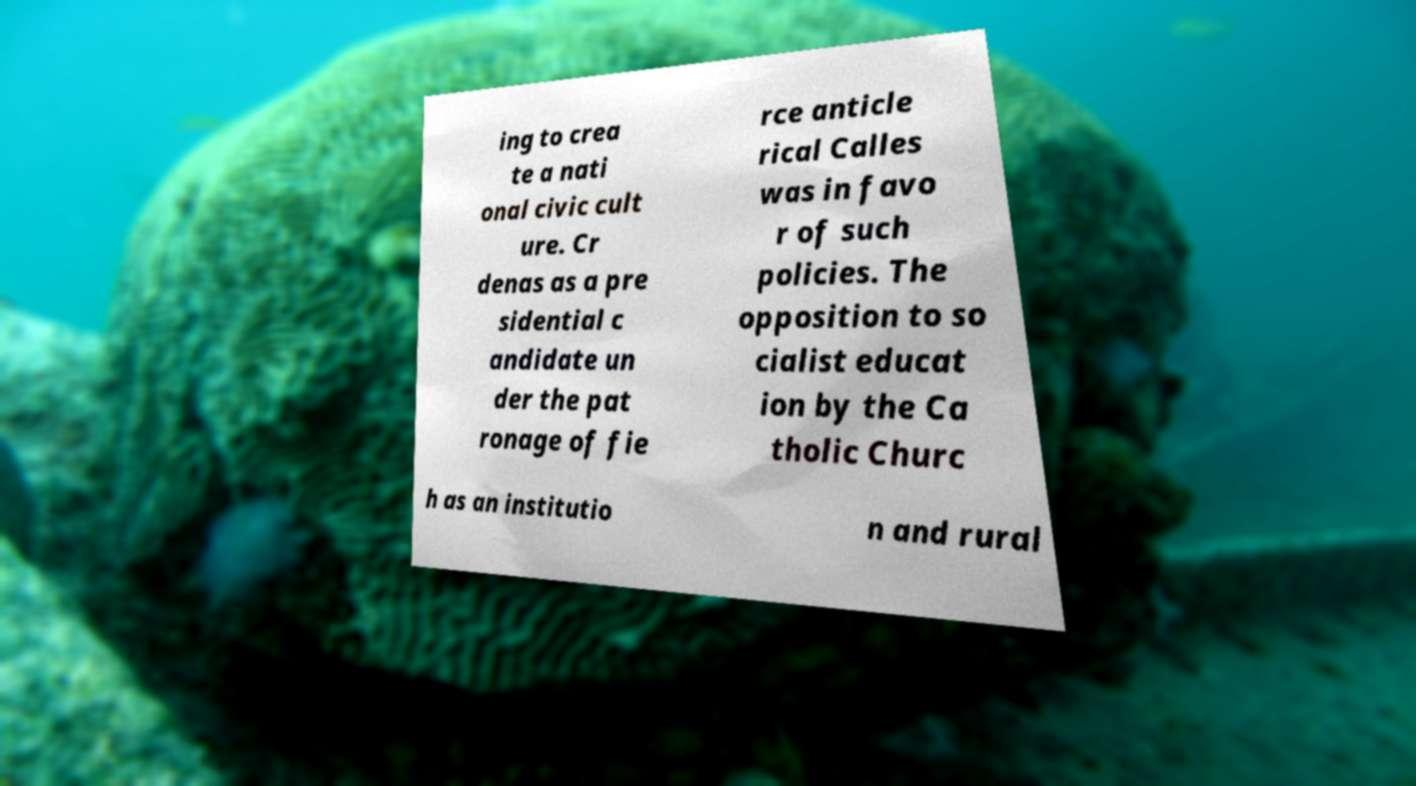Can you read and provide the text displayed in the image?This photo seems to have some interesting text. Can you extract and type it out for me? ing to crea te a nati onal civic cult ure. Cr denas as a pre sidential c andidate un der the pat ronage of fie rce anticle rical Calles was in favo r of such policies. The opposition to so cialist educat ion by the Ca tholic Churc h as an institutio n and rural 